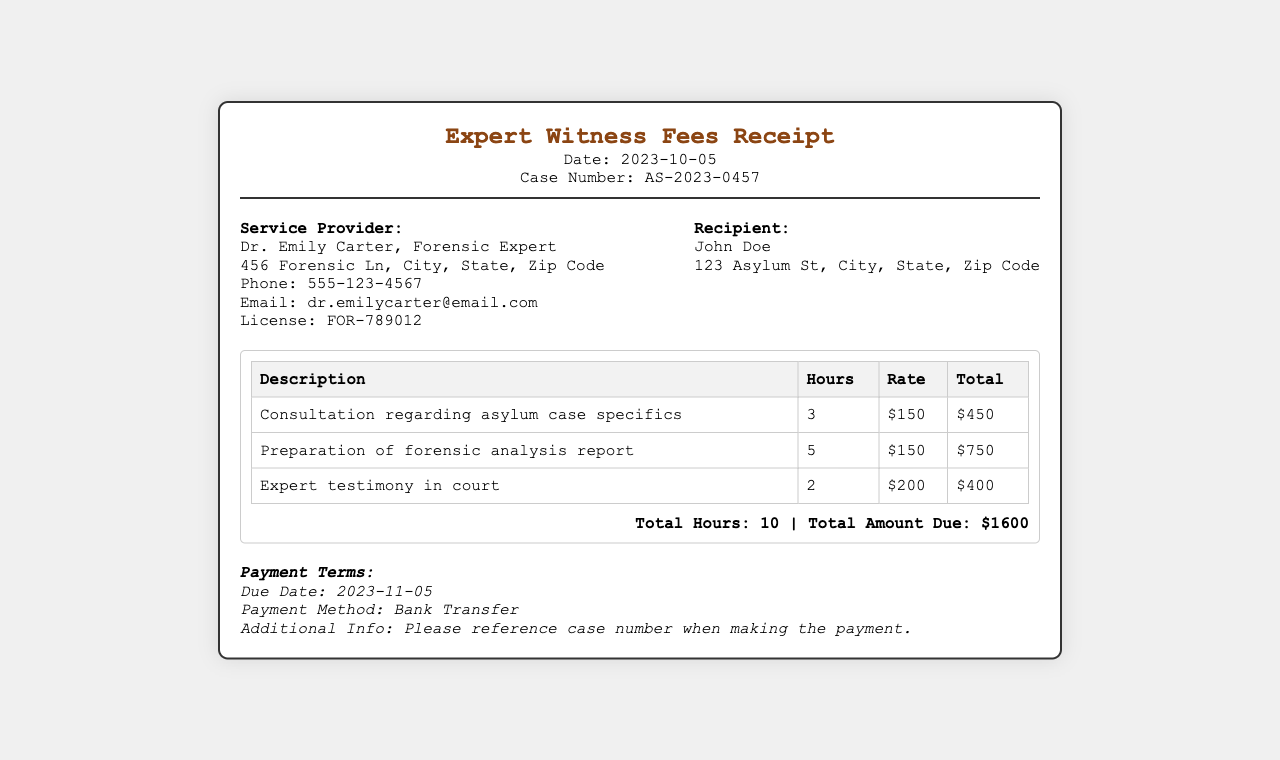What is the date of the receipt? The date of the receipt is clearly indicated in the header section.
Answer: 2023-10-05 Who is the service provider? The document includes the name of the service provider under the provider info section.
Answer: Dr. Emily Carter, Forensic Expert What is the case number? The case number is listed in the header and is essential for identification.
Answer: AS-2023-0457 How many total hours were worked? The total hours worked can be found in the summary section of the document.
Answer: 10 What is the total amount due? The total amount due is also mentioned in the summary section at the bottom.
Answer: $1600 How much was charged for the expert testimony in court? The table details the charge for each service, including the expert testimony.
Answer: $400 What is the hourly rate for forensic analysis report preparation? The rate is specified in the services table next to that service.
Answer: $150 When is the payment due? The due date for payment is stated in the payment terms section.
Answer: 2023-11-05 What payment method is accepted? The accepted payment method is indicated in the payment terms on the receipt.
Answer: Bank Transfer 